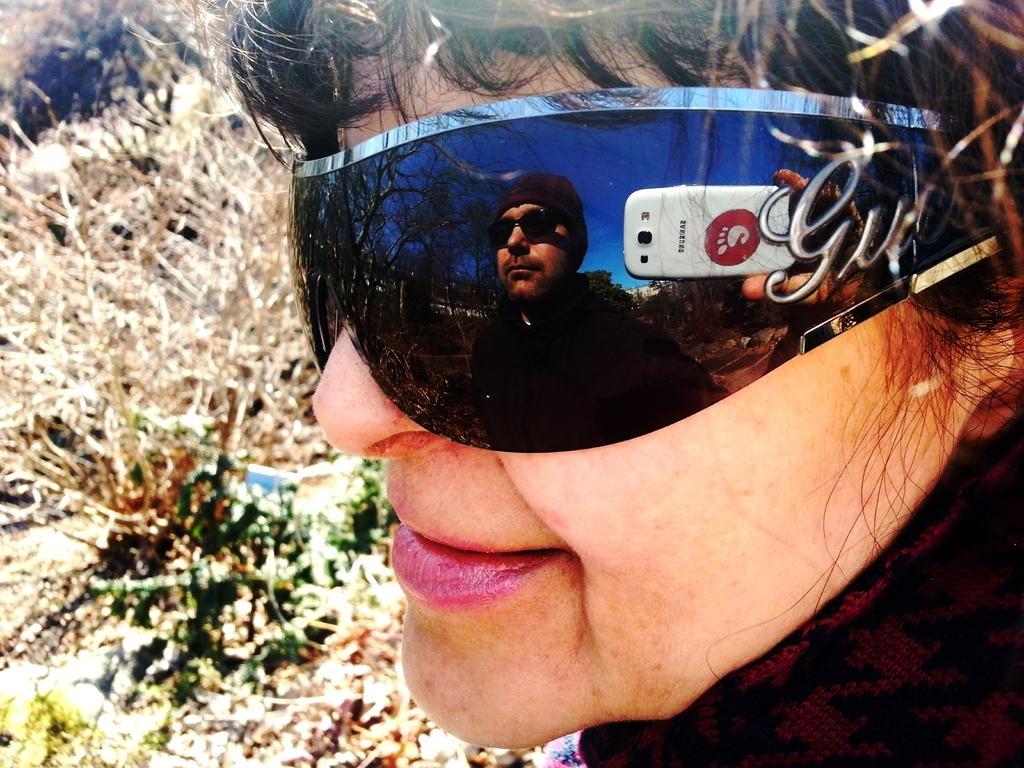Can you describe this image briefly? In this image we can see a woman wearing glasses. We can see a person holding a mobile reflected on her glasses. On the backside we can see some plants. 